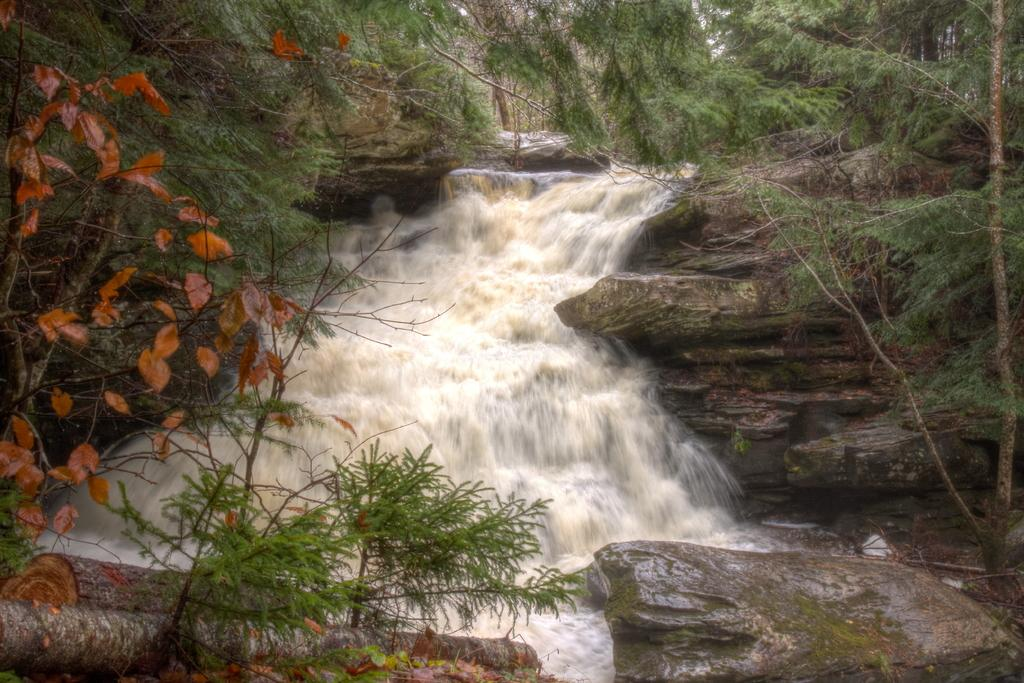What is the primary element visible in the image? There is water in the image. What other objects or features can be seen in the image? There are rocks and trees on either side of the water. What type of body is visible in the image? There is no body present in the image; it features water, rocks, and trees. What is the purpose of the coal in the image? There is no coal present in the image. 